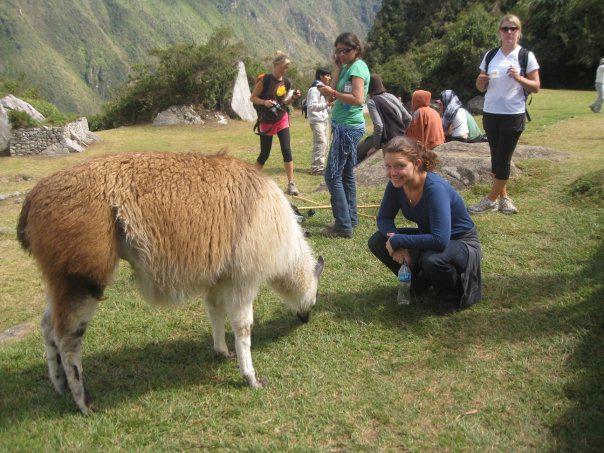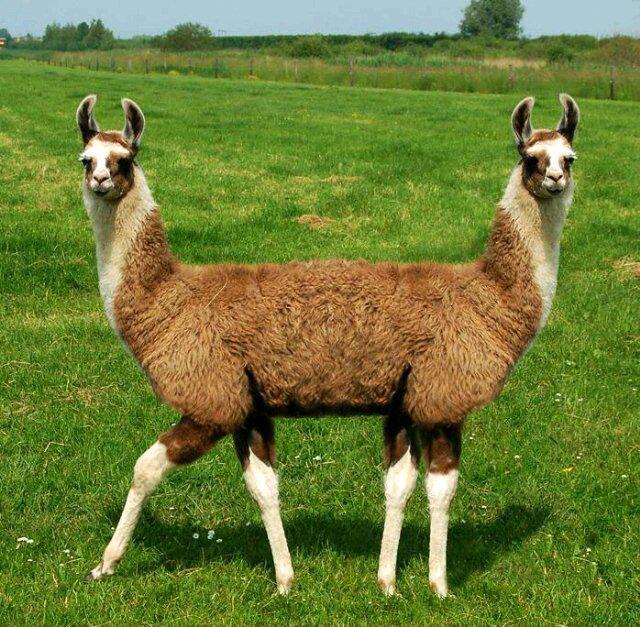The first image is the image on the left, the second image is the image on the right. For the images shown, is this caption "There is exactly one llama in the left image." true? Answer yes or no. Yes. 